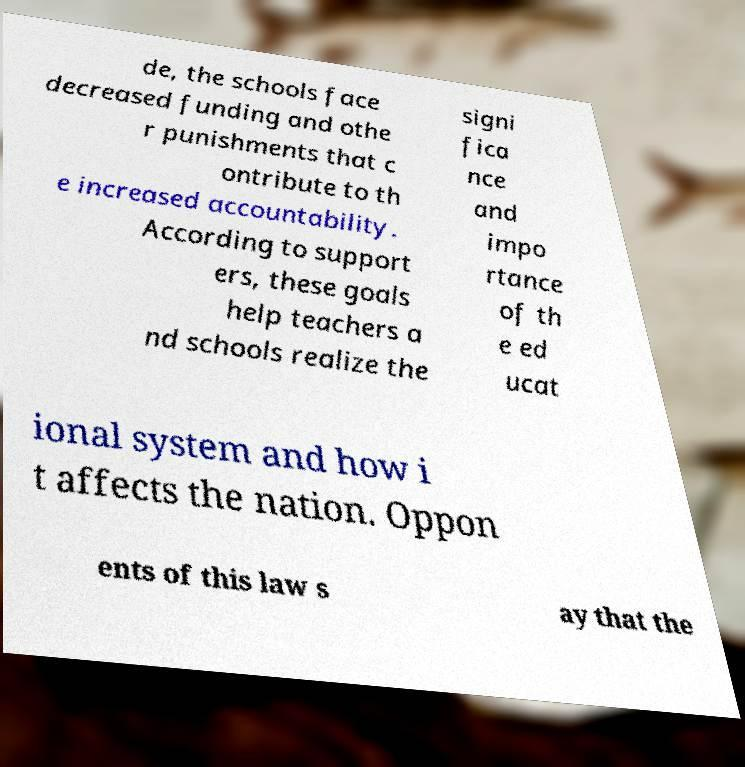Can you accurately transcribe the text from the provided image for me? de, the schools face decreased funding and othe r punishments that c ontribute to th e increased accountability. According to support ers, these goals help teachers a nd schools realize the signi fica nce and impo rtance of th e ed ucat ional system and how i t affects the nation. Oppon ents of this law s ay that the 